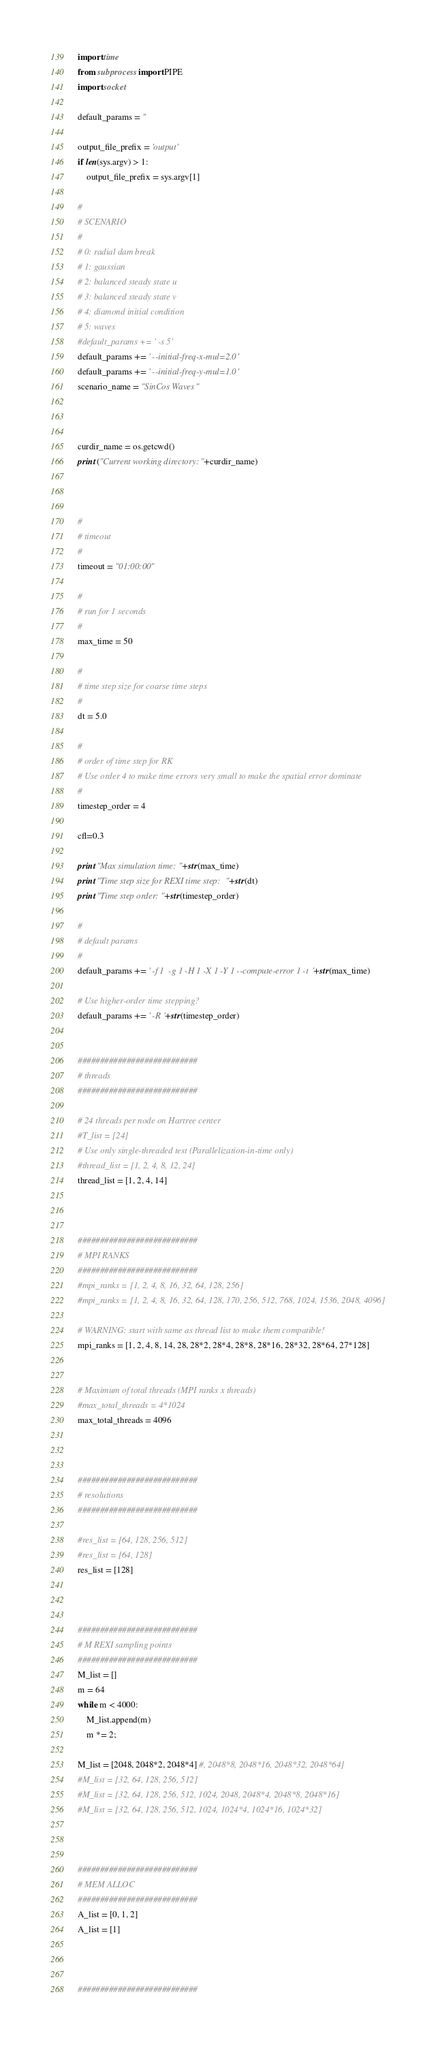Convert code to text. <code><loc_0><loc_0><loc_500><loc_500><_Python_>import time
from subprocess import PIPE
import socket

default_params = ''

output_file_prefix = 'output'
if len(sys.argv) > 1:
	output_file_prefix = sys.argv[1]

#
# SCENARIO
#
# 0: radial dam break
# 1: gaussian
# 2: balanced steady state u
# 3: balanced steady state v
# 4: diamond initial condition
# 5: waves
#default_params += ' -s 5'
default_params += ' --initial-freq-x-mul=2.0'
default_params += ' --initial-freq-y-mul=1.0'
scenario_name = "SinCos Waves"



curdir_name = os.getcwd()
print ("Current working directory: "+curdir_name)



#
# timeout
#
timeout = "01:00:00"

#
# run for 1 seconds
#
max_time = 50

#
# time step size for coarse time steps
#
dt = 5.0

#
# order of time step for RK
# Use order 4 to make time errors very small to make the spatial error dominate
#
timestep_order = 4

cfl=0.3

print "Max simulation time: "+str(max_time)
print "Time step size for REXI time step: "+str(dt)
print "Time step order: "+str(timestep_order)

#
# default params
#
default_params += ' -f 1  -g 1 -H 1 -X 1 -Y 1 --compute-error 1 -t '+str(max_time)

# Use higher-order time stepping?
default_params += ' -R '+str(timestep_order)


###########################
# threads
###########################

# 24 threads per node on Hartree center
#T_list = [24]
# Use only single-threaded test (Parallelization-in-time only)
#thread_list = [1, 2, 4, 8, 12, 24]
thread_list = [1, 2, 4, 14]



###########################
# MPI RANKS
###########################
#mpi_ranks = [1, 2, 4, 8, 16, 32, 64, 128, 256]
#mpi_ranks = [1, 2, 4, 8, 16, 32, 64, 128, 170, 256, 512, 768, 1024, 1536, 2048, 4096]

# WARNING: start with same as thread list to make them compatible!
mpi_ranks = [1, 2, 4, 8, 14, 28, 28*2, 28*4, 28*8, 28*16, 28*32, 28*64, 27*128]


# Maximum of total threads (MPI ranks x threads)
#max_total_threads = 4*1024
max_total_threads = 4096



###########################
# resolutions
###########################

#res_list = [64, 128, 256, 512]
#res_list = [64, 128]
res_list = [128]



###########################
# M REXI sampling points
###########################
M_list = []
m = 64
while m < 4000:
	M_list.append(m)
	m *= 2;

M_list = [2048, 2048*2, 2048*4] #, 2048*8, 2048*16, 2048*32, 2048*64]
#M_list = [32, 64, 128, 256, 512]
#M_list = [32, 64, 128, 256, 512, 1024, 2048, 2048*4, 2048*8, 2048*16]
#M_list = [32, 64, 128, 256, 512, 1024, 1024*4, 1024*16, 1024*32]



###########################
# MEM ALLOC
###########################
A_list = [0, 1, 2]
A_list = [1]



###########################</code> 